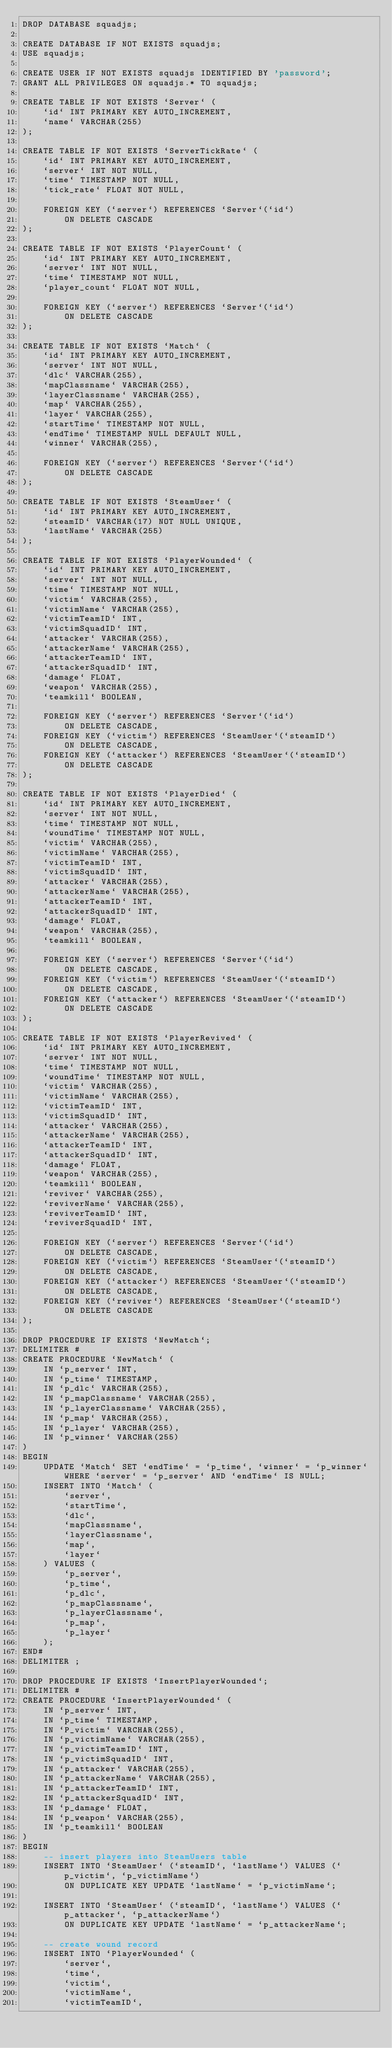Convert code to text. <code><loc_0><loc_0><loc_500><loc_500><_SQL_>DROP DATABASE squadjs;

CREATE DATABASE IF NOT EXISTS squadjs;
USE squadjs;

CREATE USER IF NOT EXISTS squadjs IDENTIFIED BY 'password';
GRANT ALL PRIVILEGES ON squadjs.* TO squadjs;

CREATE TABLE IF NOT EXISTS `Server` (
    `id` INT PRIMARY KEY AUTO_INCREMENT,
    `name` VARCHAR(255)
);

CREATE TABLE IF NOT EXISTS `ServerTickRate` (
    `id` INT PRIMARY KEY AUTO_INCREMENT,
    `server` INT NOT NULL,
    `time` TIMESTAMP NOT NULL,
    `tick_rate` FLOAT NOT NULL,

    FOREIGN KEY (`server`) REFERENCES `Server`(`id`)
        ON DELETE CASCADE
);

CREATE TABLE IF NOT EXISTS `PlayerCount` (
    `id` INT PRIMARY KEY AUTO_INCREMENT,
    `server` INT NOT NULL,
    `time` TIMESTAMP NOT NULL,
    `player_count` FLOAT NOT NULL,

    FOREIGN KEY (`server`) REFERENCES `Server`(`id`)
        ON DELETE CASCADE
);

CREATE TABLE IF NOT EXISTS `Match` (
    `id` INT PRIMARY KEY AUTO_INCREMENT,
    `server` INT NOT NULL,
    `dlc` VARCHAR(255),
    `mapClassname` VARCHAR(255),
    `layerClassname` VARCHAR(255),
    `map` VARCHAR(255),
    `layer` VARCHAR(255),
    `startTime` TIMESTAMP NOT NULL,
    `endTime` TIMESTAMP NULL DEFAULT NULL,
    `winner` VARCHAR(255),
	
    FOREIGN KEY (`server`) REFERENCES `Server`(`id`)
        ON DELETE CASCADE
);

CREATE TABLE IF NOT EXISTS `SteamUser` (
    `id` INT PRIMARY KEY AUTO_INCREMENT,
    `steamID` VARCHAR(17) NOT NULL UNIQUE,
    `lastName` VARCHAR(255)
);

CREATE TABLE IF NOT EXISTS `PlayerWounded` (
    `id` INT PRIMARY KEY AUTO_INCREMENT,
    `server` INT NOT NULL,
    `time` TIMESTAMP NOT NULL,
    `victim` VARCHAR(255),
    `victimName` VARCHAR(255),
    `victimTeamID` INT,
    `victimSquadID` INT,
    `attacker` VARCHAR(255),
    `attackerName` VARCHAR(255),
    `attackerTeamID` INT,
    `attackerSquadID` INT,
    `damage` FLOAT,
    `weapon` VARCHAR(255),
    `teamkill` BOOLEAN,

    FOREIGN KEY (`server`) REFERENCES `Server`(`id`)
        ON DELETE CASCADE,
    FOREIGN KEY (`victim`) REFERENCES `SteamUser`(`steamID`)
        ON DELETE CASCADE,
    FOREIGN KEY (`attacker`) REFERENCES `SteamUser`(`steamID`)
        ON DELETE CASCADE
);

CREATE TABLE IF NOT EXISTS `PlayerDied` (
    `id` INT PRIMARY KEY AUTO_INCREMENT,
    `server` INT NOT NULL,
    `time` TIMESTAMP NOT NULL,
    `woundTime` TIMESTAMP NOT NULL,
    `victim` VARCHAR(255),
    `victimName` VARCHAR(255),
    `victimTeamID` INT,
    `victimSquadID` INT,
    `attacker` VARCHAR(255),
    `attackerName` VARCHAR(255),
    `attackerTeamID` INT,
    `attackerSquadID` INT,
    `damage` FLOAT,
    `weapon` VARCHAR(255),
    `teamkill` BOOLEAN,

    FOREIGN KEY (`server`) REFERENCES `Server`(`id`)
        ON DELETE CASCADE,
    FOREIGN KEY (`victim`) REFERENCES `SteamUser`(`steamID`)
        ON DELETE CASCADE,
    FOREIGN KEY (`attacker`) REFERENCES `SteamUser`(`steamID`)
        ON DELETE CASCADE
);

CREATE TABLE IF NOT EXISTS `PlayerRevived` (
    `id` INT PRIMARY KEY AUTO_INCREMENT,
    `server` INT NOT NULL,
    `time` TIMESTAMP NOT NULL,
    `woundTime` TIMESTAMP NOT NULL,
    `victim` VARCHAR(255),
    `victimName` VARCHAR(255),
    `victimTeamID` INT,
    `victimSquadID` INT,
    `attacker` VARCHAR(255),
    `attackerName` VARCHAR(255),
    `attackerTeamID` INT,
    `attackerSquadID` INT,
    `damage` FLOAT,
    `weapon` VARCHAR(255),
    `teamkill` BOOLEAN,
    `reviver` VARCHAR(255),
    `reviverName` VARCHAR(255),
    `reviverTeamID` INT,
    `reviverSquadID` INT,

    FOREIGN KEY (`server`) REFERENCES `Server`(`id`)
        ON DELETE CASCADE,
    FOREIGN KEY (`victim`) REFERENCES `SteamUser`(`steamID`)
        ON DELETE CASCADE,
    FOREIGN KEY (`attacker`) REFERENCES `SteamUser`(`steamID`)
        ON DELETE CASCADE,
    FOREIGN KEY (`reviver`) REFERENCES `SteamUser`(`steamID`)
        ON DELETE CASCADE
);

DROP PROCEDURE IF EXISTS `NewMatch`;
DELIMITER #
CREATE PROCEDURE `NewMatch` (
    IN `p_server` INT,
    IN `p_time` TIMESTAMP,
    IN `p_dlc` VARCHAR(255),
    IN `p_mapClassname` VARCHAR(255),
    IN `p_layerClassname` VARCHAR(255),
    IN `p_map` VARCHAR(255),
    IN `p_layer` VARCHAR(255),
	IN `p_winner` VARCHAR(255)
)
BEGIN
    UPDATE `Match` SET `endTime` = `p_time`, `winner` = `p_winner` WHERE `server` = `p_server` AND `endTime` IS NULL;
    INSERT INTO `Match` (
        `server`,
        `startTime`,
        `dlc`,
        `mapClassname`,
        `layerClassname`,
        `map`,
        `layer`
    ) VALUES (
        `p_server`,
        `p_time`,
        `p_dlc`,
        `p_mapClassname`,
        `p_layerClassname`,
        `p_map`,
        `p_layer`
    );
END#
DELIMITER ;

DROP PROCEDURE IF EXISTS `InsertPlayerWounded`;
DELIMITER #
CREATE PROCEDURE `InsertPlayerWounded` (
    IN `p_server` INT,
    IN `p_time` TIMESTAMP,
    IN `P_victim` VARCHAR(255),
    IN `p_victimName` VARCHAR(255),
    IN `p_victimTeamID` INT,
    IN `p_victimSquadID` INT,
    IN `p_attacker` VARCHAR(255),
    IN `p_attackerName` VARCHAR(255),
    IN `p_attackerTeamID` INT,
    IN `p_attackerSquadID` INT,
    IN `p_damage` FLOAT,
    IN `p_weapon` VARCHAR(255),
    IN `p_teamkill` BOOLEAN
)
BEGIN
    -- insert players into SteamUsers table
    INSERT INTO `SteamUser` (`steamID`, `lastName`) VALUES (`p_victim`, `p_victimName`)
        ON DUPLICATE KEY UPDATE `lastName` = `p_victimName`;

    INSERT INTO `SteamUser` (`steamID`, `lastName`) VALUES (`p_attacker`, `p_attackerName`)
        ON DUPLICATE KEY UPDATE `lastName` = `p_attackerName`;

    -- create wound record
    INSERT INTO `PlayerWounded` (
        `server`,
        `time`,
        `victim`,
        `victimName`,
        `victimTeamID`,</code> 